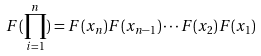<formula> <loc_0><loc_0><loc_500><loc_500>F ( \prod _ { i = 1 } ^ { n } ) = F ( x _ { n } ) F ( x _ { n - 1 } ) \cdots F ( x _ { 2 } ) F ( x _ { 1 } )</formula> 